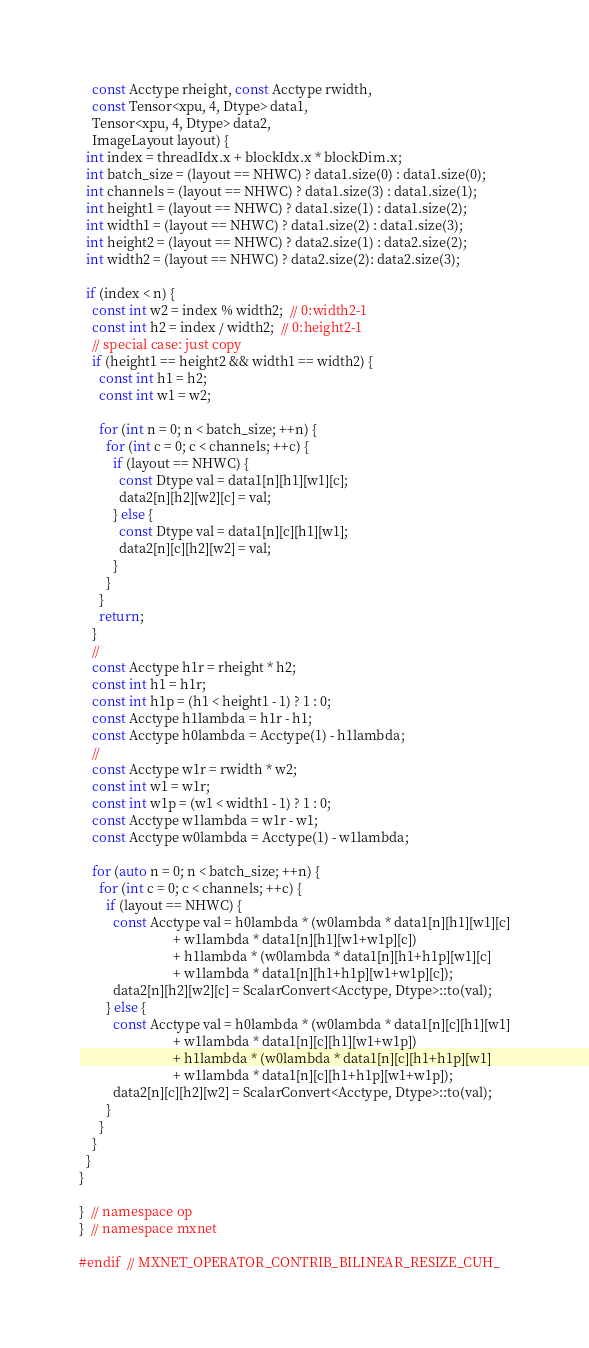<code> <loc_0><loc_0><loc_500><loc_500><_Cuda_>    const Acctype rheight, const Acctype rwidth,
    const Tensor<xpu, 4, Dtype> data1,
    Tensor<xpu, 4, Dtype> data2,
    ImageLayout layout) {
  int index = threadIdx.x + blockIdx.x * blockDim.x;
  int batch_size = (layout == NHWC) ? data1.size(0) : data1.size(0);
  int channels = (layout == NHWC) ? data1.size(3) : data1.size(1);
  int height1 = (layout == NHWC) ? data1.size(1) : data1.size(2);
  int width1 = (layout == NHWC) ? data1.size(2) : data1.size(3);
  int height2 = (layout == NHWC) ? data2.size(1) : data2.size(2);
  int width2 = (layout == NHWC) ? data2.size(2): data2.size(3);

  if (index < n) {
    const int w2 = index % width2;  // 0:width2-1
    const int h2 = index / width2;  // 0:height2-1
    // special case: just copy
    if (height1 == height2 && width1 == width2) {
      const int h1 = h2;
      const int w1 = w2;

      for (int n = 0; n < batch_size; ++n) {
        for (int c = 0; c < channels; ++c) {
          if (layout == NHWC) {
            const Dtype val = data1[n][h1][w1][c];
            data2[n][h2][w2][c] = val;
          } else {
            const Dtype val = data1[n][c][h1][w1];
            data2[n][c][h2][w2] = val;
          }
        }
      }
      return;
    }
    //
    const Acctype h1r = rheight * h2;
    const int h1 = h1r;
    const int h1p = (h1 < height1 - 1) ? 1 : 0;
    const Acctype h1lambda = h1r - h1;
    const Acctype h0lambda = Acctype(1) - h1lambda;
    //
    const Acctype w1r = rwidth * w2;
    const int w1 = w1r;
    const int w1p = (w1 < width1 - 1) ? 1 : 0;
    const Acctype w1lambda = w1r - w1;
    const Acctype w0lambda = Acctype(1) - w1lambda;

    for (auto n = 0; n < batch_size; ++n) {
      for (int c = 0; c < channels; ++c) {
        if (layout == NHWC) {
          const Acctype val = h0lambda * (w0lambda * data1[n][h1][w1][c]
                            + w1lambda * data1[n][h1][w1+w1p][c])
                            + h1lambda * (w0lambda * data1[n][h1+h1p][w1][c]
                            + w1lambda * data1[n][h1+h1p][w1+w1p][c]);
          data2[n][h2][w2][c] = ScalarConvert<Acctype, Dtype>::to(val);
        } else {
          const Acctype val = h0lambda * (w0lambda * data1[n][c][h1][w1]
                            + w1lambda * data1[n][c][h1][w1+w1p])
                            + h1lambda * (w0lambda * data1[n][c][h1+h1p][w1]
                            + w1lambda * data1[n][c][h1+h1p][w1+w1p]);
          data2[n][c][h2][w2] = ScalarConvert<Acctype, Dtype>::to(val);
        }
      }
    }
  }
}

}  // namespace op
}  // namespace mxnet

#endif  // MXNET_OPERATOR_CONTRIB_BILINEAR_RESIZE_CUH_</code> 